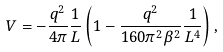<formula> <loc_0><loc_0><loc_500><loc_500>V = - \frac { q ^ { 2 } } { 4 \pi } \frac { 1 } { L } \left ( { 1 - \frac { q ^ { 2 } } { 1 6 0 \pi ^ { 2 } \beta ^ { 2 } } \frac { 1 } { L ^ { 4 } } } \right ) ,</formula> 